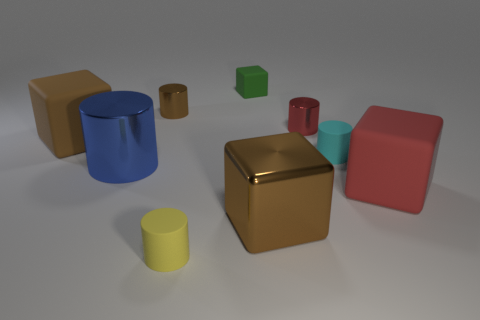There is a red cylinder that is left of the large rubber cube that is to the right of the brown cube that is in front of the large red rubber block; what is it made of?
Ensure brevity in your answer.  Metal. There is a large brown block that is right of the brown metallic thing that is behind the shiny block; what is it made of?
Your answer should be compact. Metal. Are there fewer rubber cylinders in front of the big brown shiny cube than rubber things?
Your answer should be very brief. Yes. The cyan object that is behind the metal block has what shape?
Your response must be concise. Cylinder. Do the red metallic cylinder and the yellow cylinder that is on the left side of the cyan cylinder have the same size?
Give a very brief answer. Yes. Are there any large things made of the same material as the small red cylinder?
Ensure brevity in your answer.  Yes. What number of blocks are either small brown objects or large matte things?
Provide a short and direct response. 2. Are there any brown cubes in front of the rubber cube that is to the left of the tiny green cube?
Your answer should be compact. Yes. Is the number of tiny green rubber objects less than the number of cyan metallic things?
Provide a short and direct response. No. What number of cyan objects have the same shape as the brown rubber object?
Your response must be concise. 0. 